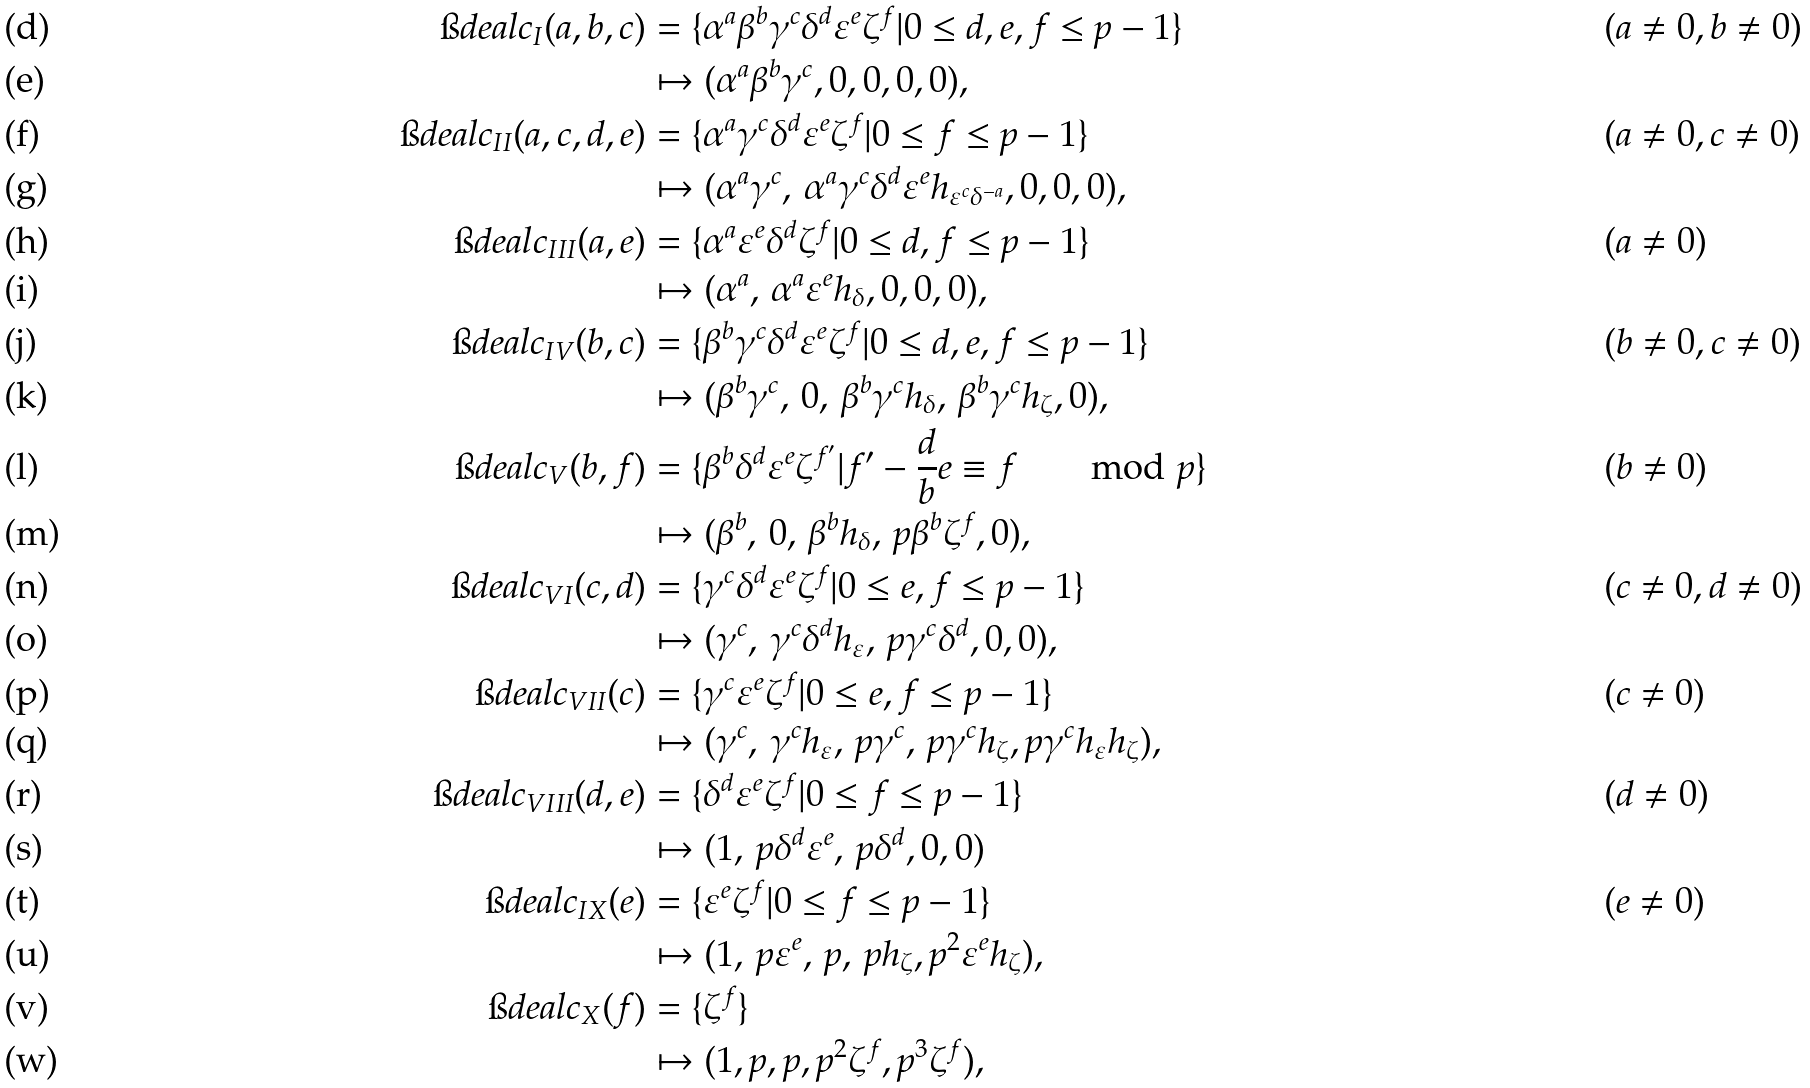<formula> <loc_0><loc_0><loc_500><loc_500>\i d e a l { c } _ { I } ( a , b , c ) & = \{ \alpha ^ { a } \beta ^ { b } \gamma ^ { c } \delta ^ { d } \varepsilon ^ { e } \zeta ^ { f } | 0 \leq d , e , f \leq p - 1 \} & & ( a \neq 0 , b \neq 0 ) \\ & \mapsto ( \alpha ^ { a } \beta ^ { b } \gamma ^ { c } , 0 , 0 , 0 , 0 ) , & \\ \i d e a l { c } _ { I I } ( a , c , d , e ) & = \{ \alpha ^ { a } \gamma ^ { c } \delta ^ { d } \varepsilon ^ { e } \zeta ^ { f } | 0 \leq f \leq p - 1 \} & & ( a \neq 0 , c \neq 0 ) \\ & \mapsto ( \alpha ^ { a } \gamma ^ { c } , \, \alpha ^ { a } \gamma ^ { c } \delta ^ { d } \varepsilon ^ { e } h _ { \varepsilon ^ { c } \delta ^ { - a } } , 0 , 0 , 0 ) , & \\ \i d e a l { c } _ { I I I } ( a , e ) & = \{ \alpha ^ { a } \varepsilon ^ { e } \delta ^ { d } \zeta ^ { f } | 0 \leq d , f \leq p - 1 \} & & ( a \neq 0 ) \\ & \mapsto ( \alpha ^ { a } , \, \alpha ^ { a } \varepsilon ^ { e } h _ { \delta } , 0 , 0 , 0 ) , \\ \i d e a l { c } _ { I V } ( b , c ) & = \{ \beta ^ { b } \gamma ^ { c } \delta ^ { d } \varepsilon ^ { e } \zeta ^ { f } | 0 \leq d , e , f \leq p - 1 \} & & ( b \neq 0 , c \neq 0 ) \\ & \mapsto ( \beta ^ { b } \gamma ^ { c } , \, 0 , \, \beta ^ { b } \gamma ^ { c } h _ { \delta } , \, \beta ^ { b } \gamma ^ { c } h _ { \zeta } , 0 ) , & \\ \i d e a l { c } _ { V } ( b , f ) & = \{ \beta ^ { b } \delta ^ { d } \varepsilon ^ { e } \zeta ^ { f ^ { \prime } } | f ^ { \prime } - \frac { d } { b } e \equiv f \quad \mod { p } \} & & ( b \neq 0 ) \\ & \mapsto ( \beta ^ { b } , \, 0 , \, \beta ^ { b } h _ { \delta } , \, p \beta ^ { b } \zeta ^ { f } , 0 ) , & \\ \i d e a l { c } _ { V I } ( c , d ) & = \{ \gamma ^ { c } \delta ^ { d } \varepsilon ^ { e } \zeta ^ { f } | 0 \leq e , f \leq p - 1 \} & & ( c \neq 0 , d \neq 0 ) \\ & \mapsto ( \gamma ^ { c } , \, \gamma ^ { c } \delta ^ { d } h _ { \varepsilon } , \, p \gamma ^ { c } \delta ^ { d } , 0 , 0 ) , & \\ \i d e a l { c } _ { V I I } ( c ) & = \{ \gamma ^ { c } \varepsilon ^ { e } \zeta ^ { f } | 0 \leq e , f \leq p - 1 \} & & ( c \neq 0 ) \\ & \mapsto ( \gamma ^ { c } , \, \gamma ^ { c } h _ { \varepsilon } , \, p \gamma ^ { c } , \, p \gamma ^ { c } h _ { \zeta } , p \gamma ^ { c } h _ { \varepsilon } h _ { \zeta } ) , & \\ \i d e a l { c } _ { V I I I } ( d , e ) & = \{ \delta ^ { d } \varepsilon ^ { e } \zeta ^ { f } | 0 \leq f \leq p - 1 \} & & ( d \neq 0 ) \\ & \mapsto ( 1 , \, p \delta ^ { d } \varepsilon ^ { e } , \, p \delta ^ { d } , 0 , 0 ) & \\ \i d e a l { c } _ { I X } ( e ) & = \{ \varepsilon ^ { e } \zeta ^ { f } | 0 \leq f \leq p - 1 \} & & ( e \neq 0 ) \\ & \mapsto ( 1 , \, p \varepsilon ^ { e } , \, p , \, p h _ { \zeta } , p ^ { 2 } \varepsilon ^ { e } h _ { \zeta } ) , & \\ \i d e a l { c } _ { X } ( f ) & = \{ \zeta ^ { f } \} & & \\ & \mapsto ( 1 , p , p , p ^ { 2 } \zeta ^ { f } , p ^ { 3 } \zeta ^ { f } ) , &</formula> 